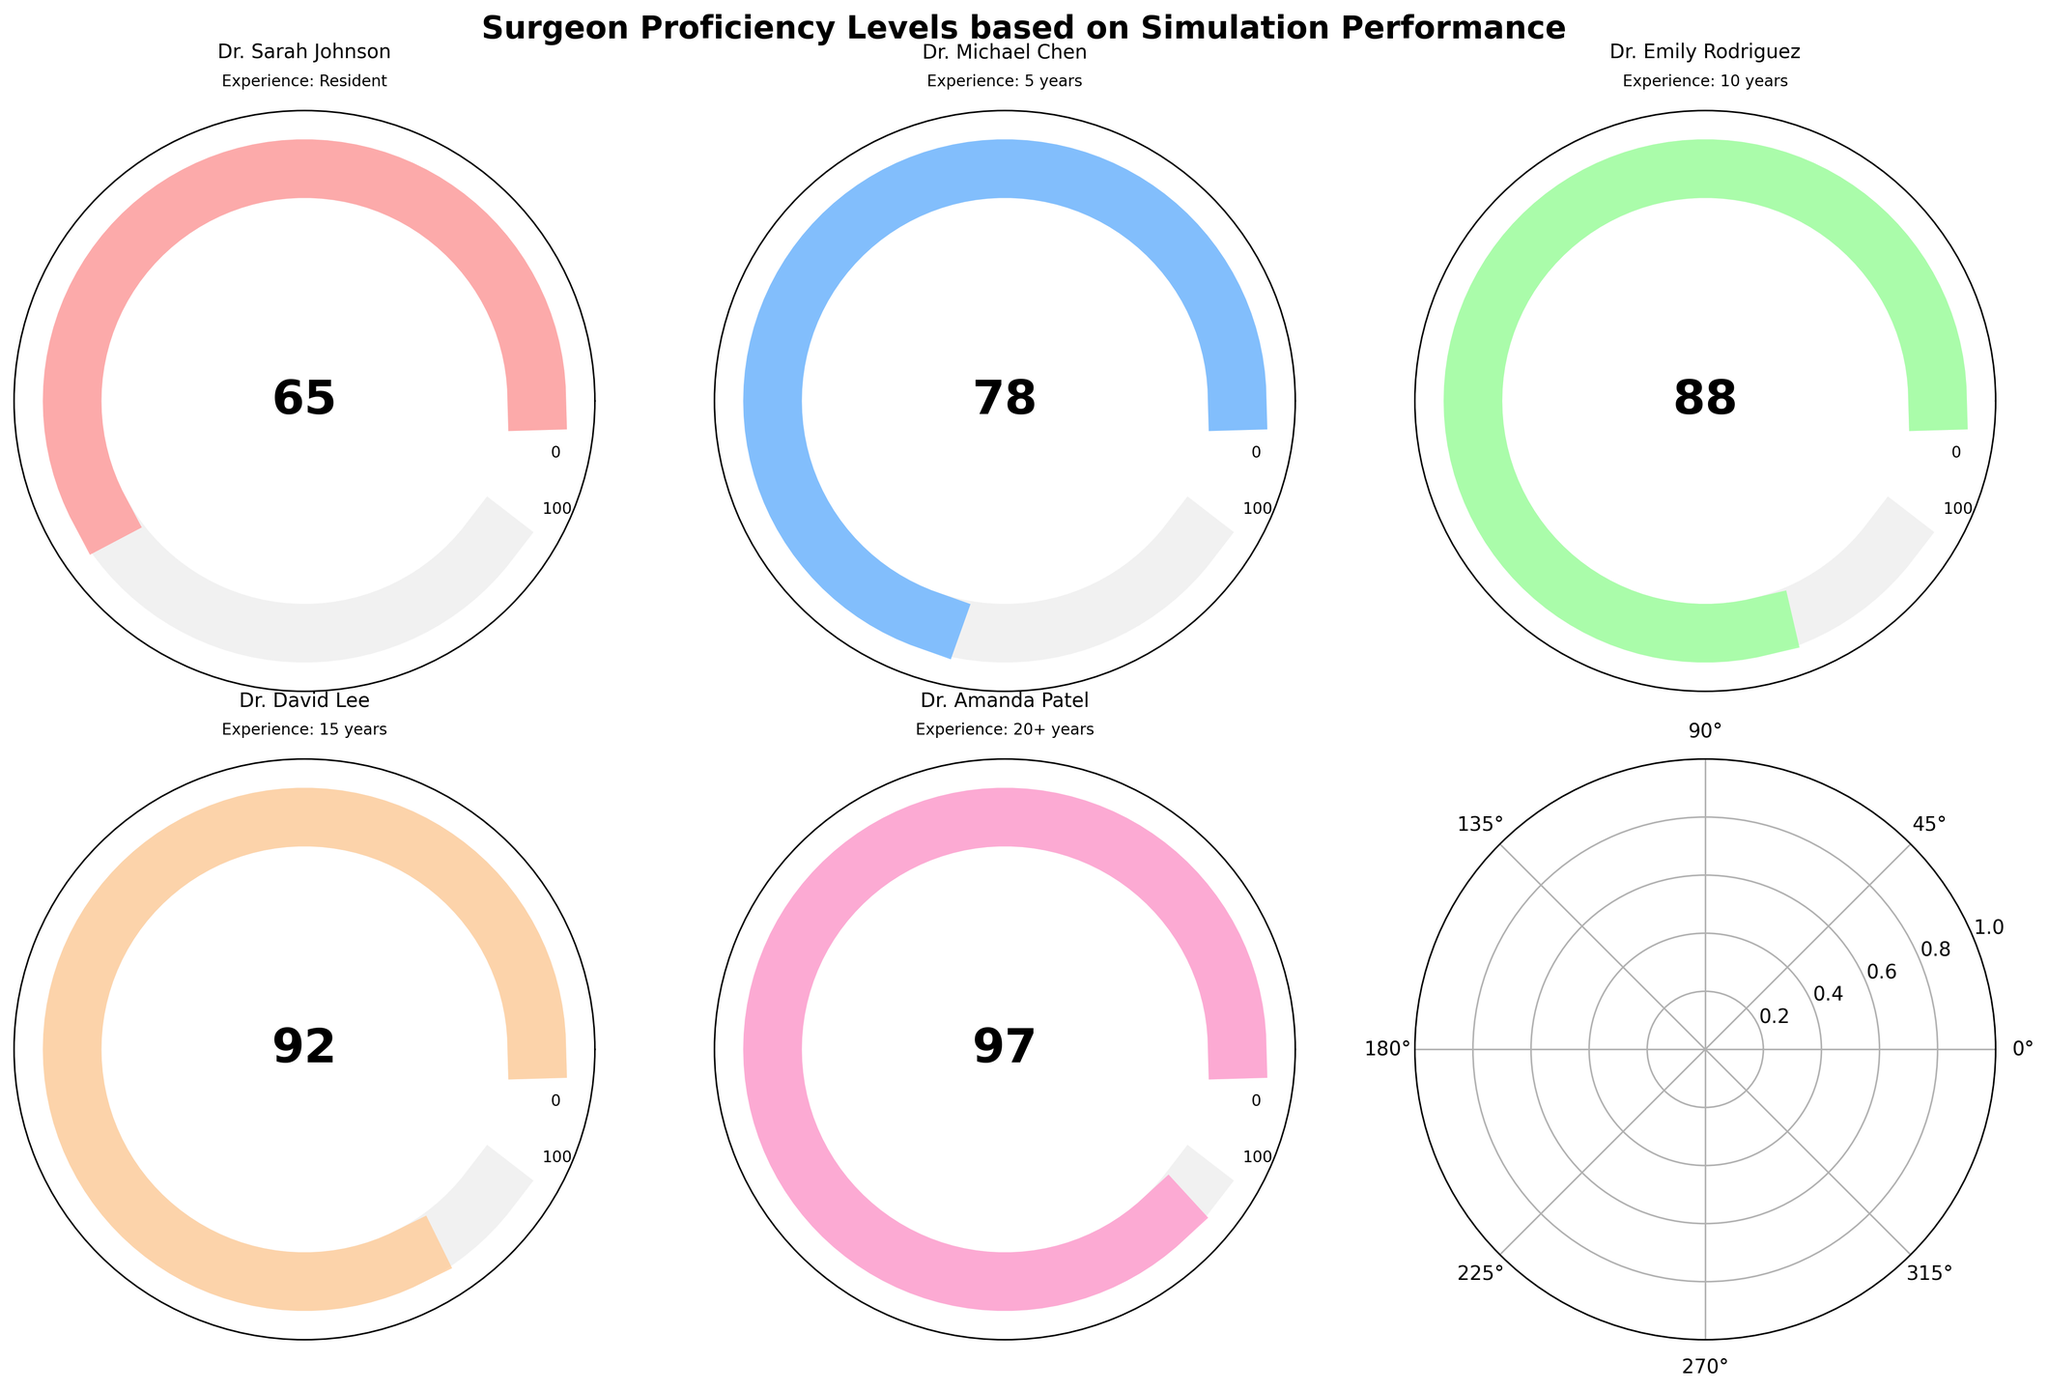Which surgeon has the highest simulation score? The surgeon with the highest score will have the gauge chart filled the most and the highest numerical value displayed. In this case, Dr. Amanda Patel has the gauge filled to 97.
Answer: Dr. Amanda Patel Which surgeon scored the lowest in the simulation? The surgeon with the lowest score will have the gauge chart filled the least and the lowest numerical value displayed. In this case, Dr. Sarah Johnson has a score of 65.
Answer: Dr. Sarah Johnson What is the average score of the surgeons? Add up the scores of all surgeons and then divide by the number of surgeons: (65 + 78 + 88 + 92 + 97) / 5 = 84
Answer: 84 How much higher is Dr. Emily Rodriguez’s score compared to Dr. Michael Chen’s score? Subtract Dr. Michael Chen’s score from Dr. Emily Rodriguez’s score: 88 - 78 = 10
Answer: 10 How does Dr. David Lee’s simulation score compare to the median score of all surgeons? First, order the scores from lowest to highest: 65, 78, 88, 92, 97. The median score is the middle value, which is 88. Dr. David Lee’s score is 92, which is 4 points higher than the median.
Answer: 4 points higher Which surgeon has an experience level of 10 years, and what is their simulation score? Check each surgeon’s experience level. Dr. Emily Rodriguez has 10 years of experience, and her simulation score is 88.
Answer: Dr. Emily Rodriguez, 88 What is the difference in simulation scores between the most experienced and least experienced surgeons? Subtract the score of the least experienced surgeon (Dr. Sarah Johnson, 65) from the score of the most experienced surgeon (Dr. Amanda Patel, 97): 97 - 65 = 32
Answer: 32 Which surgeon has a simulation score closer to 80, and how close are they? Dr. Michael Chen scored 78, which is closer to 80 compared to other surgeons. The difference is 80 - 78 = 2.
Answer: Dr. Michael Chen, 2 